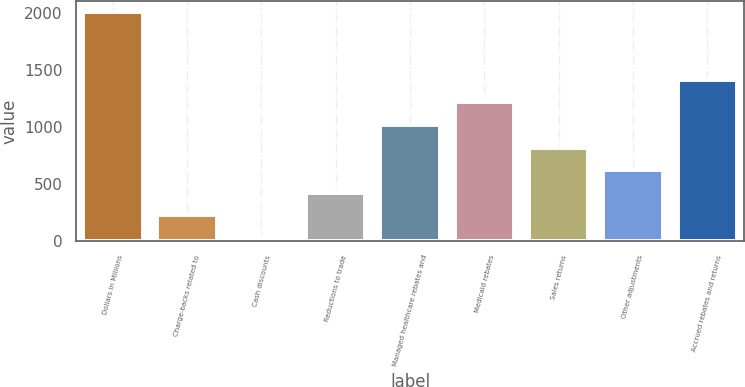<chart> <loc_0><loc_0><loc_500><loc_500><bar_chart><fcel>Dollars in Millions<fcel>Charge-backs related to<fcel>Cash discounts<fcel>Reductions to trade<fcel>Managed healthcare rebates and<fcel>Medicaid rebates<fcel>Sales returns<fcel>Other adjustments<fcel>Accrued rebates and returns<nl><fcel>2010<fcel>227.1<fcel>29<fcel>425.2<fcel>1019.5<fcel>1217.6<fcel>821.4<fcel>623.3<fcel>1415.7<nl></chart> 